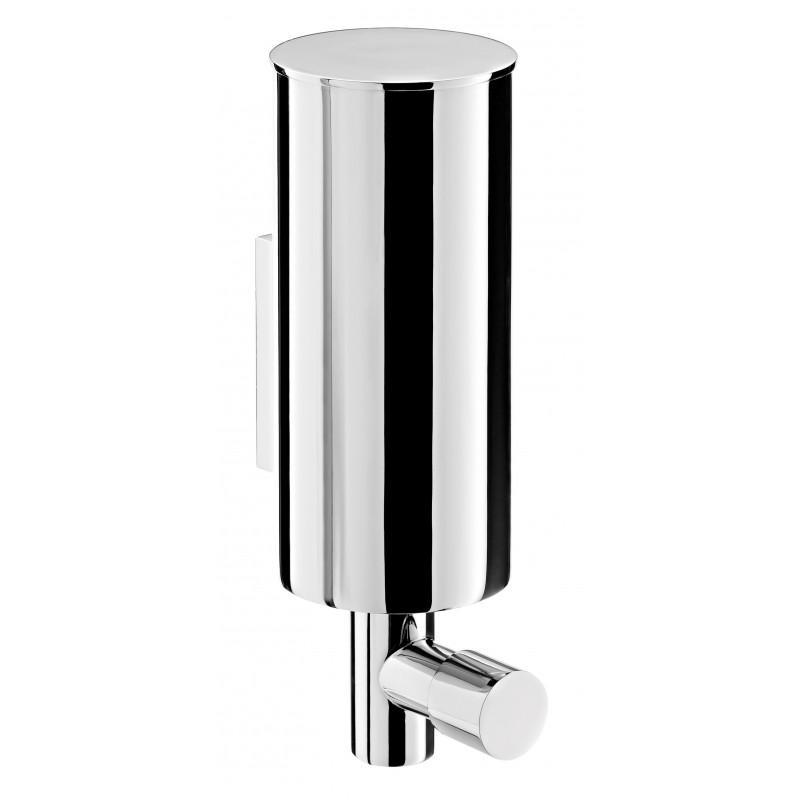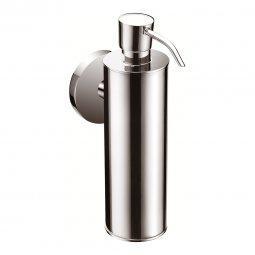The first image is the image on the left, the second image is the image on the right. Given the left and right images, does the statement "The cylindrical dispenser in one of the images has a thin tube on the spout." hold true? Answer yes or no. Yes. 